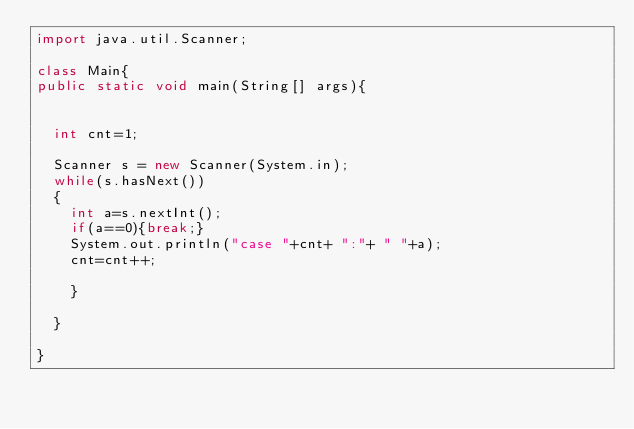<code> <loc_0><loc_0><loc_500><loc_500><_Java_>import java.util.Scanner;

class Main{
public static void main(String[] args){

	
	int cnt=1;
 
	Scanner s = new Scanner(System.in);
	while(s.hasNext())
	{
		int a=s.nextInt();
		if(a==0){break;}
		System.out.println("case "+cnt+ ":"+ " "+a);
		cnt=cnt++;
			
		}
		
	}
	
}

</code> 